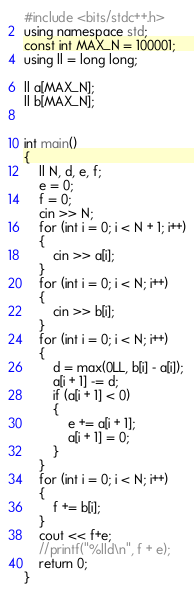Convert code to text. <code><loc_0><loc_0><loc_500><loc_500><_C++_>#include <bits/stdc++.h>
using namespace std;
const int MAX_N = 100001;
using ll = long long;

ll a[MAX_N];
ll b[MAX_N];


int main()
{
    ll N, d, e, f;
    e = 0;
    f = 0;
    cin >> N;
    for (int i = 0; i < N + 1; i++)
    {
        cin >> a[i];
    }
    for (int i = 0; i < N; i++)
    {
        cin >> b[i];
    }
    for (int i = 0; i < N; i++)
    {
        d = max(0LL, b[i] - a[i]);
        a[i + 1] -= d;
        if (a[i + 1] < 0)
        {
            e += a[i + 1];
            a[i + 1] = 0;
        }
    }
    for (int i = 0; i < N; i++)
    {
        f += b[i];
    }
    cout << f+e;
    //printf("%lld\n", f + e);
    return 0;
}

</code> 